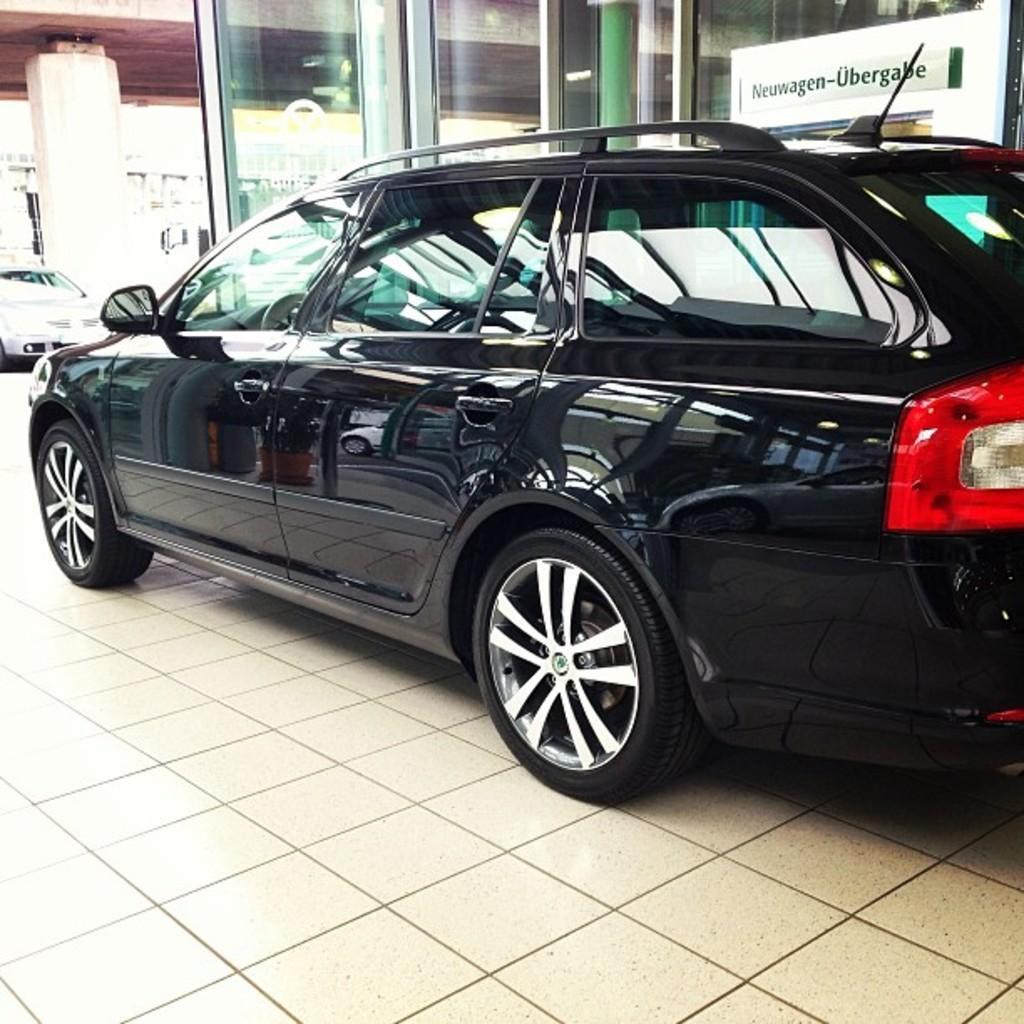How would you summarize this image in a sentence or two? In this image we can see motor vehicles on the floor. In the background there are buildings, glasses and a name board. 